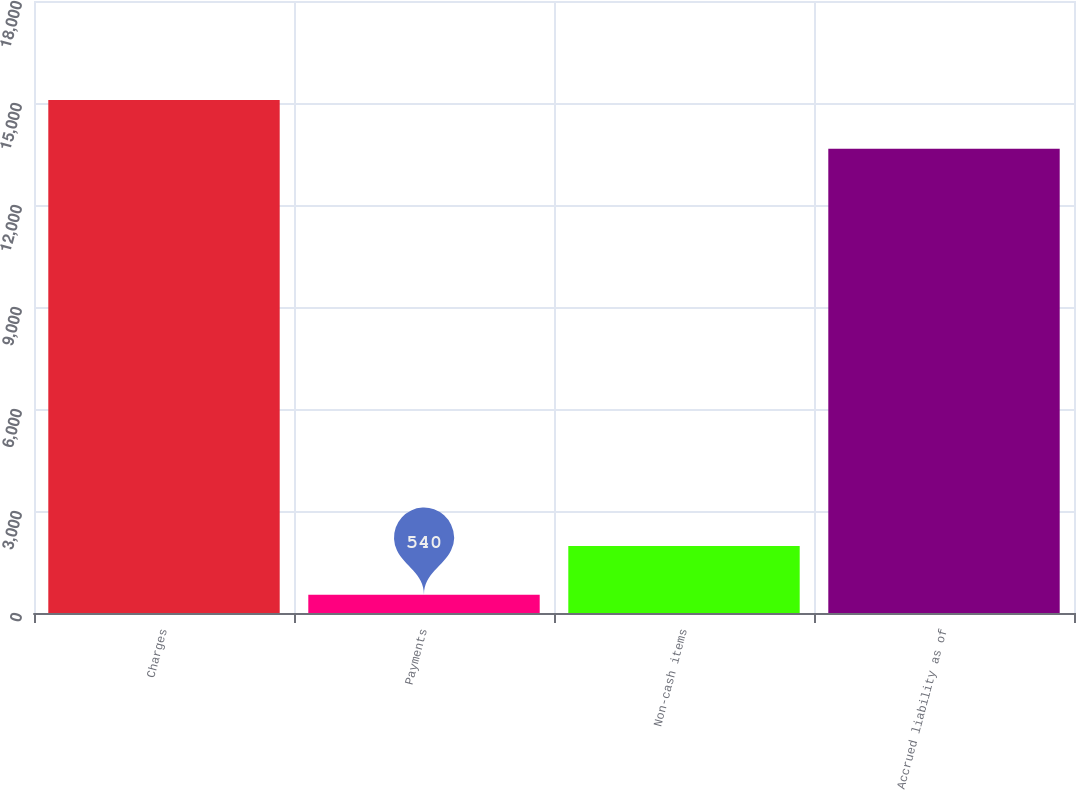Convert chart. <chart><loc_0><loc_0><loc_500><loc_500><bar_chart><fcel>Charges<fcel>Payments<fcel>Non-cash items<fcel>Accrued liability as of<nl><fcel>15088.7<fcel>540<fcel>1970.7<fcel>13658<nl></chart> 